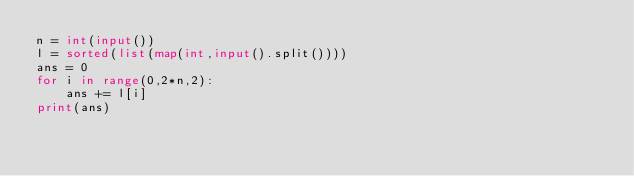Convert code to text. <code><loc_0><loc_0><loc_500><loc_500><_Python_>n = int(input())
l = sorted(list(map(int,input().split())))
ans = 0
for i in range(0,2*n,2):
    ans += l[i]
print(ans)</code> 